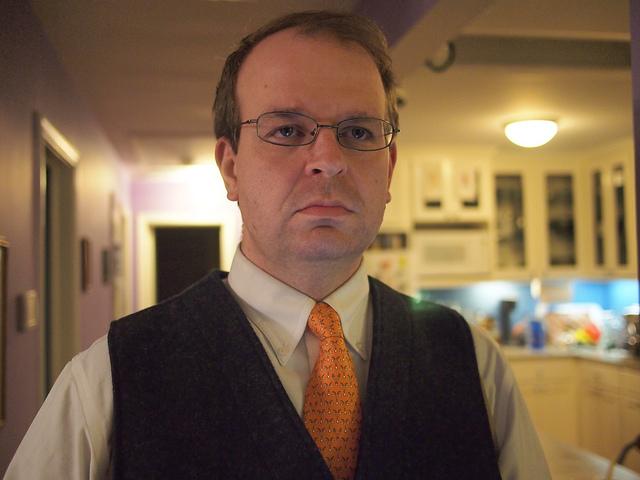Is the man wearing glasses?
Concise answer only. Yes. Is the man a house Butler?
Short answer required. No. What color is the tie?
Be succinct. Orange. Is this person happy?
Short answer required. No. 